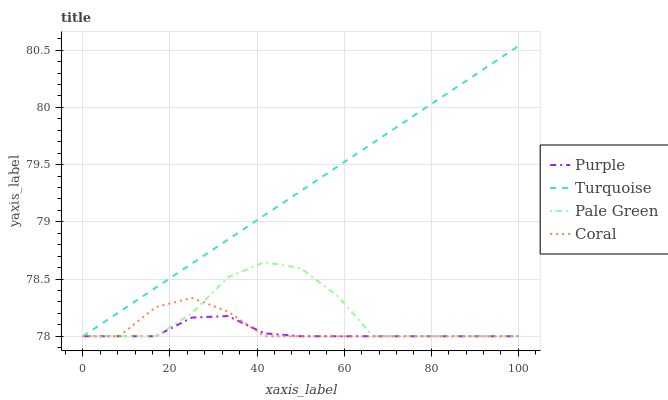Does Purple have the minimum area under the curve?
Answer yes or no. Yes. Does Turquoise have the maximum area under the curve?
Answer yes or no. Yes. Does Pale Green have the minimum area under the curve?
Answer yes or no. No. Does Pale Green have the maximum area under the curve?
Answer yes or no. No. Is Turquoise the smoothest?
Answer yes or no. Yes. Is Pale Green the roughest?
Answer yes or no. Yes. Is Pale Green the smoothest?
Answer yes or no. No. Is Turquoise the roughest?
Answer yes or no. No. Does Purple have the lowest value?
Answer yes or no. Yes. Does Turquoise have the highest value?
Answer yes or no. Yes. Does Pale Green have the highest value?
Answer yes or no. No. Does Purple intersect Turquoise?
Answer yes or no. Yes. Is Purple less than Turquoise?
Answer yes or no. No. Is Purple greater than Turquoise?
Answer yes or no. No. 